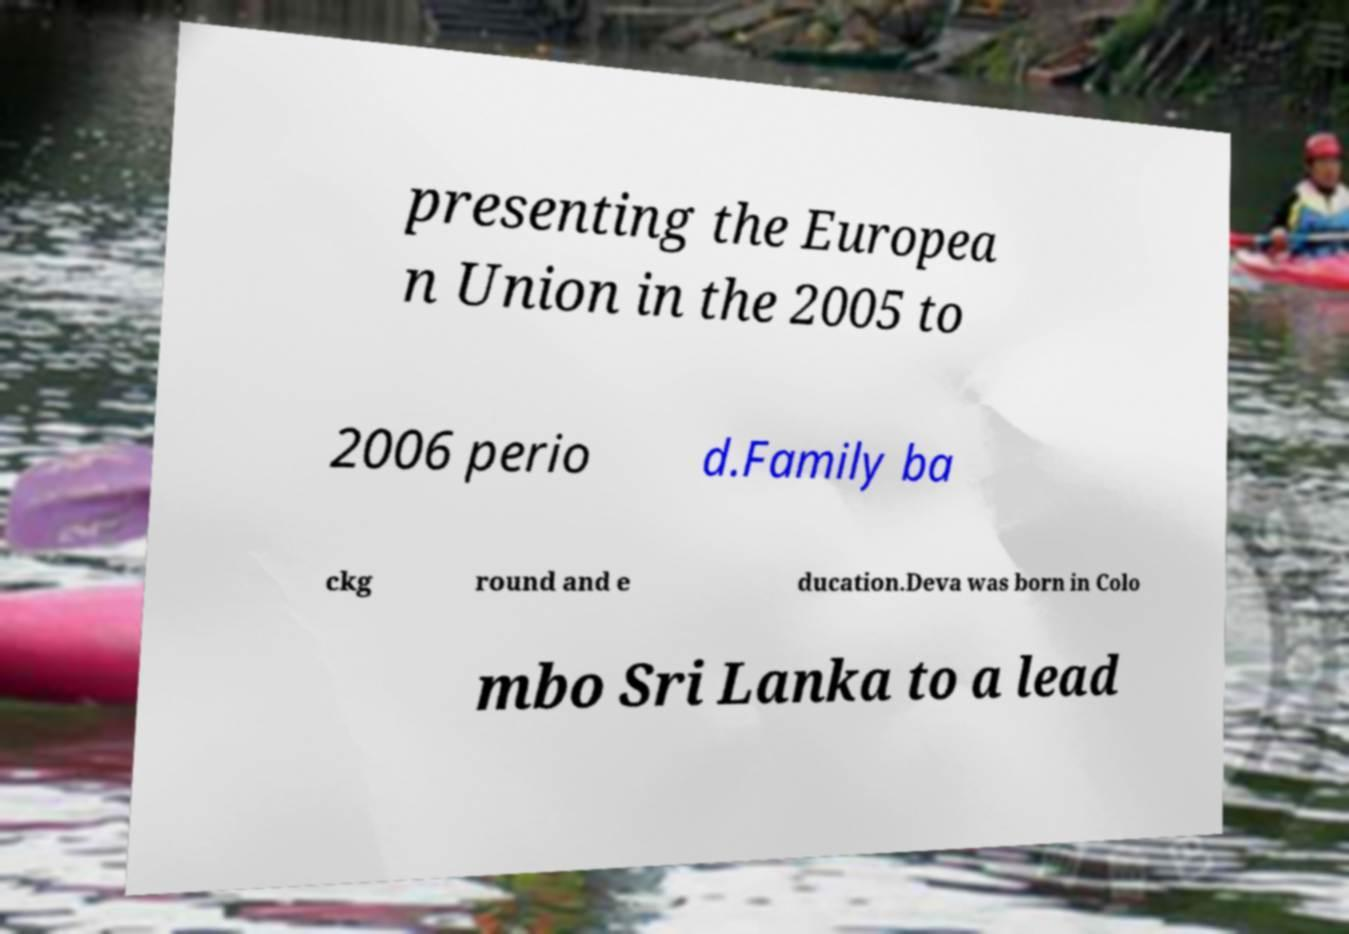Please identify and transcribe the text found in this image. presenting the Europea n Union in the 2005 to 2006 perio d.Family ba ckg round and e ducation.Deva was born in Colo mbo Sri Lanka to a lead 